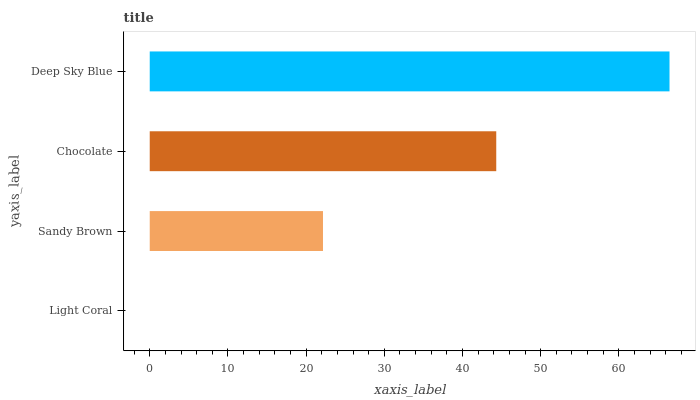Is Light Coral the minimum?
Answer yes or no. Yes. Is Deep Sky Blue the maximum?
Answer yes or no. Yes. Is Sandy Brown the minimum?
Answer yes or no. No. Is Sandy Brown the maximum?
Answer yes or no. No. Is Sandy Brown greater than Light Coral?
Answer yes or no. Yes. Is Light Coral less than Sandy Brown?
Answer yes or no. Yes. Is Light Coral greater than Sandy Brown?
Answer yes or no. No. Is Sandy Brown less than Light Coral?
Answer yes or no. No. Is Chocolate the high median?
Answer yes or no. Yes. Is Sandy Brown the low median?
Answer yes or no. Yes. Is Light Coral the high median?
Answer yes or no. No. Is Chocolate the low median?
Answer yes or no. No. 